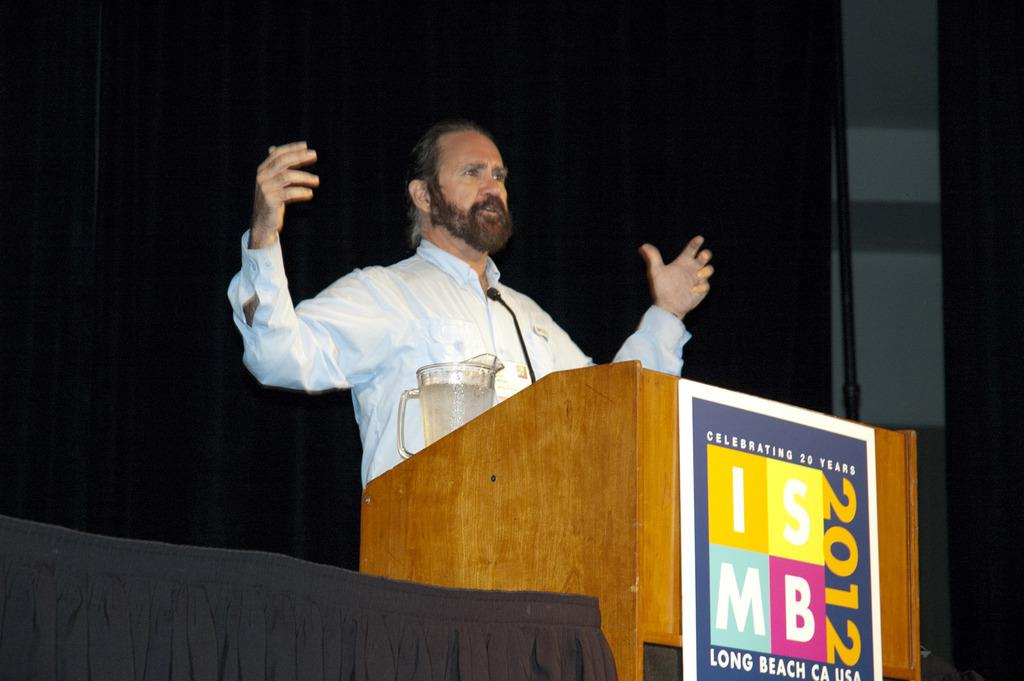<image>
Present a compact description of the photo's key features. Man giving a presentation with a podium that says ISMB 2012. 